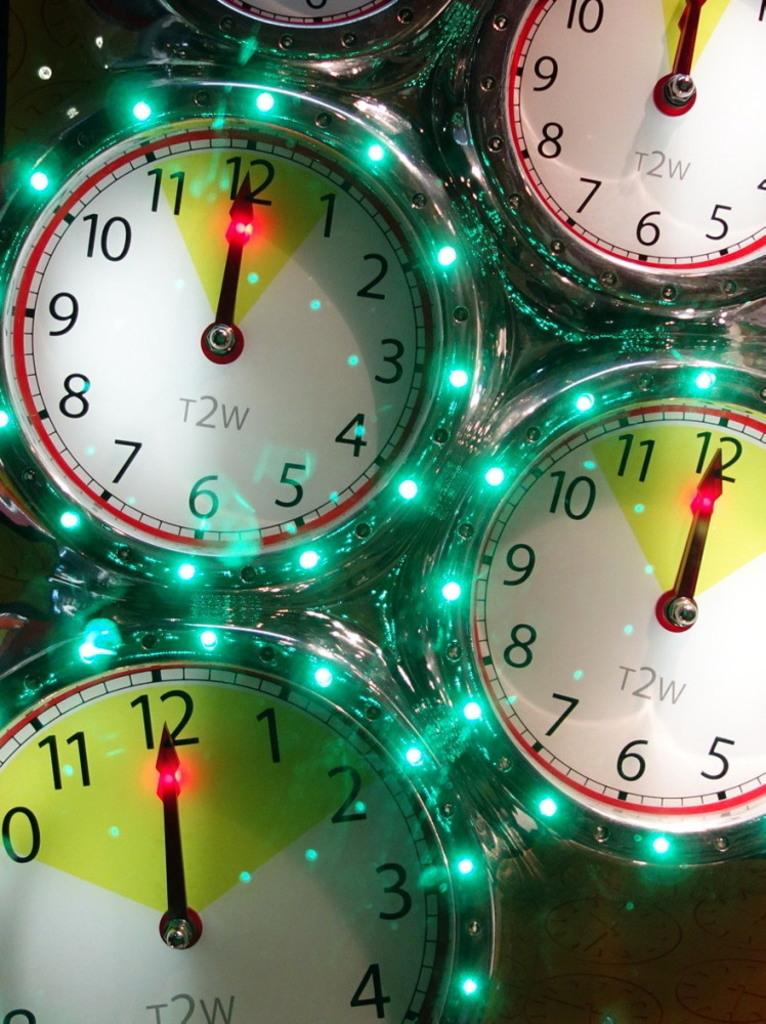How many clocks can you see?
Your answer should be compact. Answering does not require reading text in the image. 